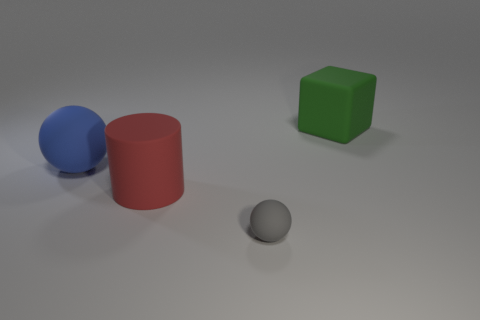Are there any other things that are the same size as the gray rubber object?
Provide a succinct answer. No. There is a thing that is both on the left side of the block and right of the large red matte object; what is its color?
Your response must be concise. Gray. There is a cylinder; are there any rubber things left of it?
Offer a very short reply. Yes. Does the matte object that is right of the gray object have the same size as the sphere left of the big red matte cylinder?
Provide a short and direct response. Yes. Are there any rubber spheres of the same size as the green cube?
Give a very brief answer. Yes. There is a rubber thing right of the small gray ball; is its shape the same as the large red object?
Keep it short and to the point. No. What shape is the large green object that is to the right of the large matte thing that is in front of the blue rubber thing?
Your answer should be compact. Cube. Do the gray rubber object and the large rubber thing that is to the left of the large red cylinder have the same shape?
Make the answer very short. Yes. There is a rubber thing that is in front of the red rubber cylinder; what number of rubber balls are behind it?
Ensure brevity in your answer.  1. What material is the other blue object that is the same shape as the small object?
Ensure brevity in your answer.  Rubber. 